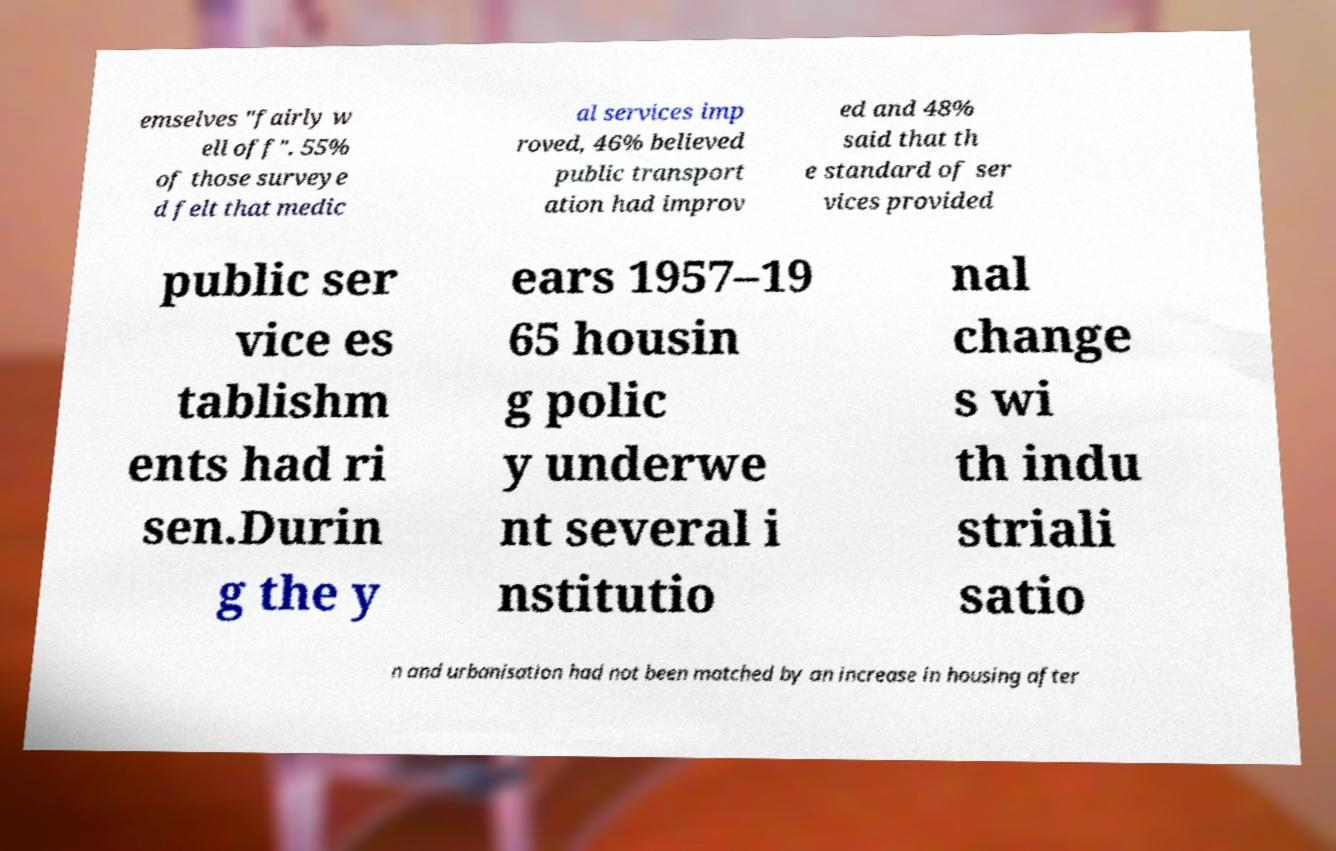Please read and relay the text visible in this image. What does it say? emselves "fairly w ell off". 55% of those surveye d felt that medic al services imp roved, 46% believed public transport ation had improv ed and 48% said that th e standard of ser vices provided public ser vice es tablishm ents had ri sen.Durin g the y ears 1957–19 65 housin g polic y underwe nt several i nstitutio nal change s wi th indu striali satio n and urbanisation had not been matched by an increase in housing after 